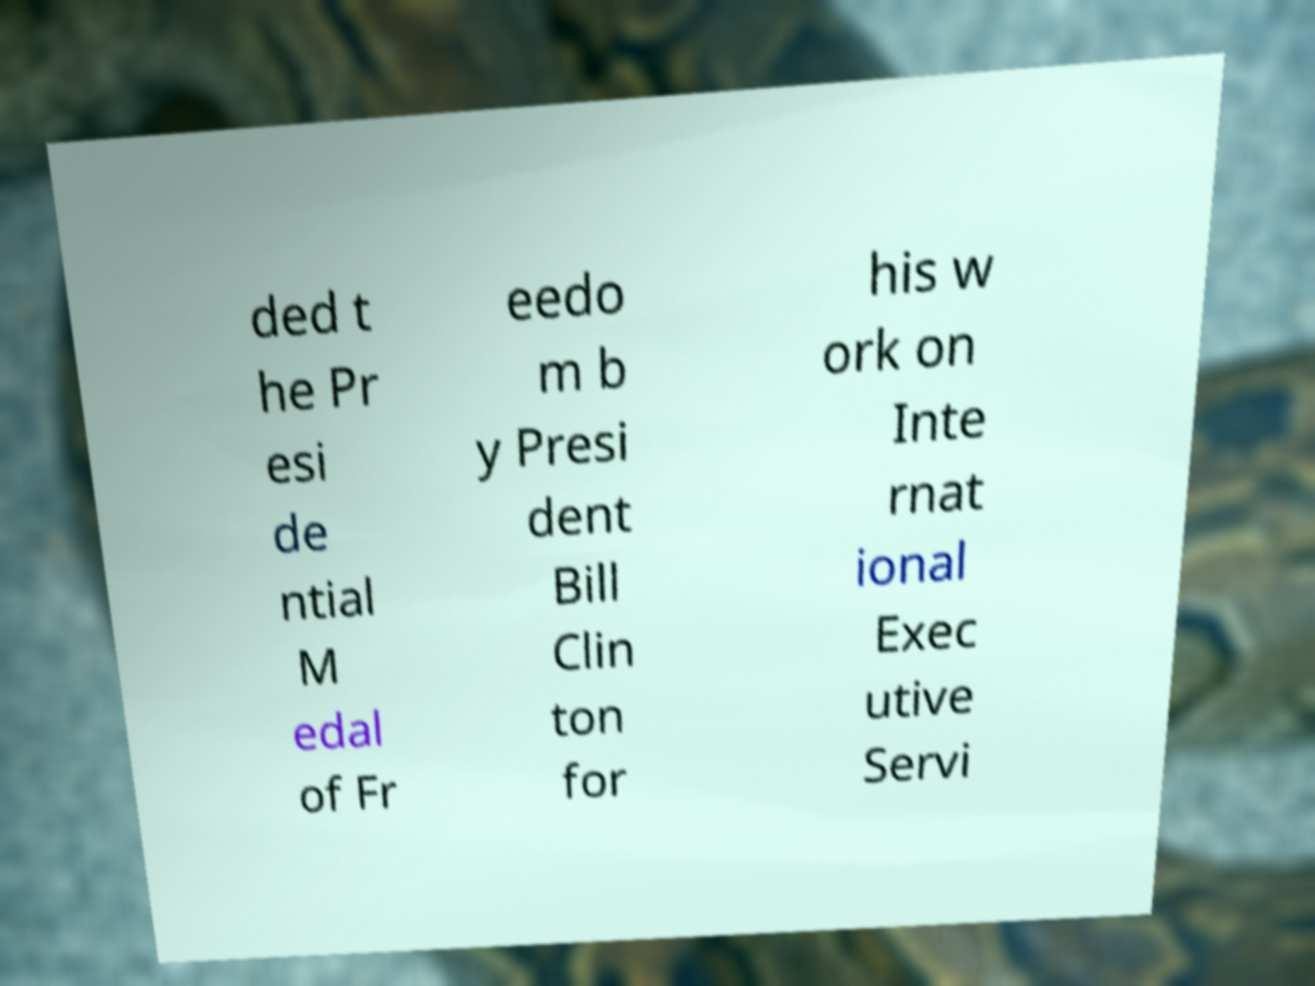There's text embedded in this image that I need extracted. Can you transcribe it verbatim? ded t he Pr esi de ntial M edal of Fr eedo m b y Presi dent Bill Clin ton for his w ork on Inte rnat ional Exec utive Servi 